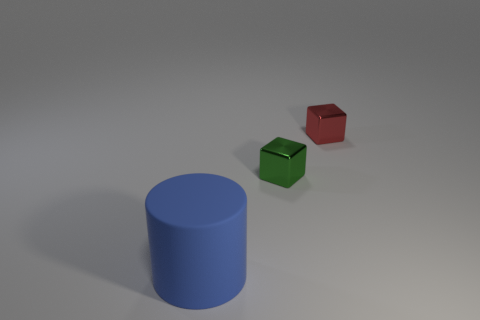Add 2 small green shiny objects. How many objects exist? 5 Subtract all cylinders. How many objects are left? 2 Subtract all big red metal cylinders. Subtract all large blue cylinders. How many objects are left? 2 Add 2 tiny green blocks. How many tiny green blocks are left? 3 Add 3 gray metal cylinders. How many gray metal cylinders exist? 3 Subtract 0 yellow balls. How many objects are left? 3 